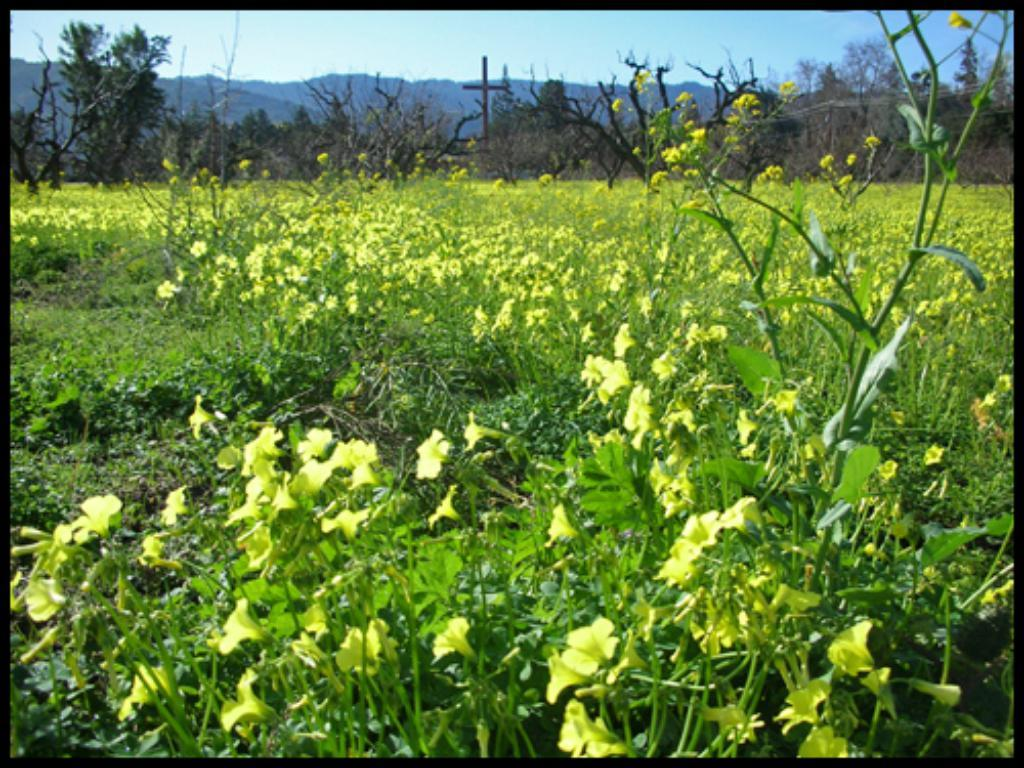What type of vegetation can be seen in the image? There are flowers, plants, and trees visible in the image. What can be seen at the top of the image? Trees, poles, hills, and the sky are visible at the top of the image. How many dinosaurs are visible in the image? There are no dinosaurs present in the image. What type of knot is used to secure the seat in the image? There is no seat present in the image, so it is not possible to determine what type of knot might be used. 